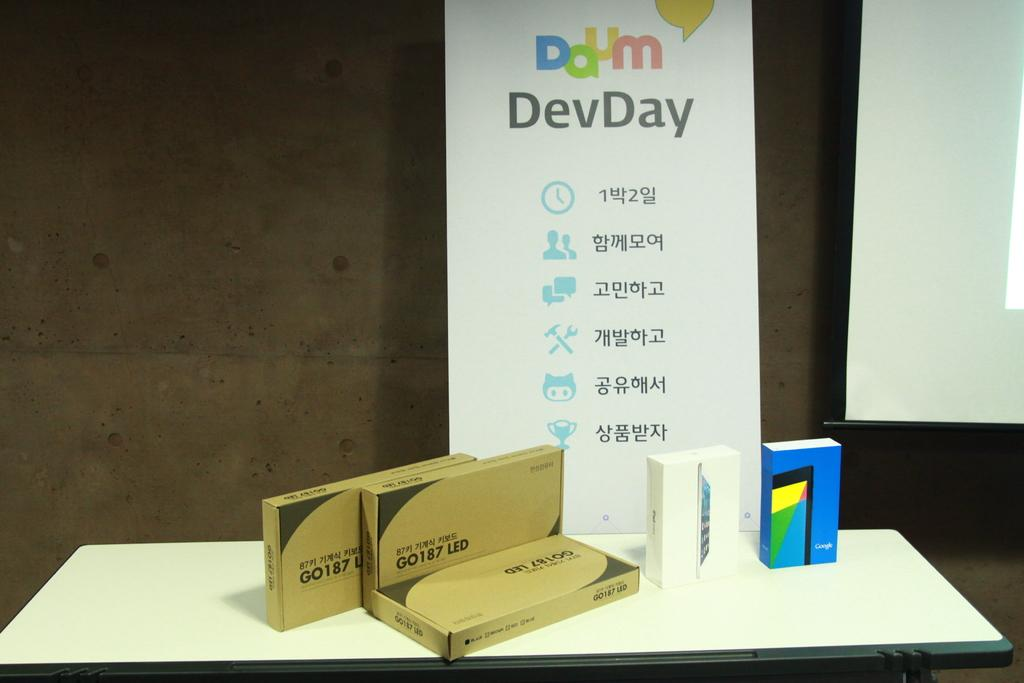<image>
Summarize the visual content of the image. A placard sits vertical on a shelf and reads DevDay. 